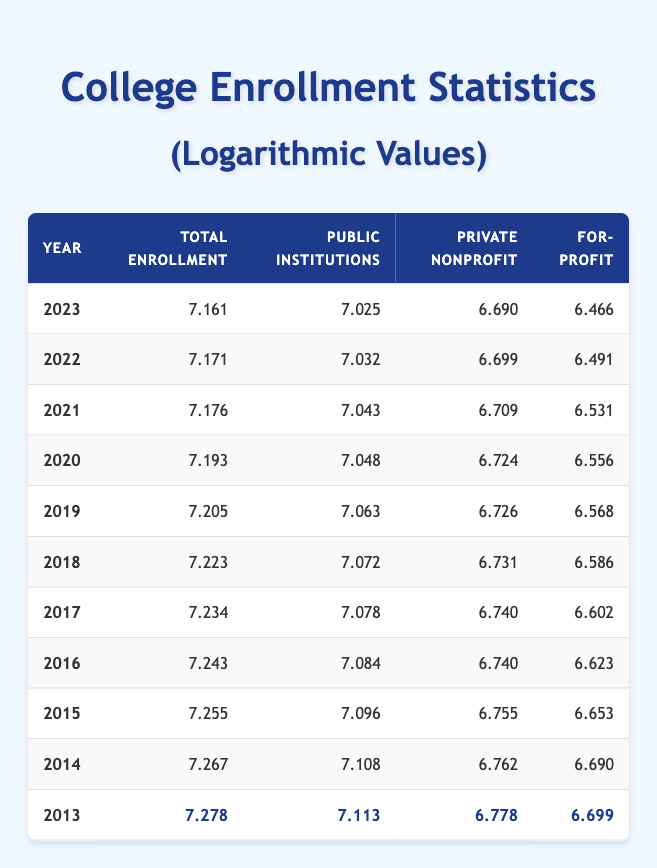What year had the highest total enrollment log value? The highest logarithmic value for total enrollment is 7.278, which corresponds to the year 2013.
Answer: 2013 What was the total enrollment in 2020? The total enrollment for the year 2020 is listed as 15600000 in the table.
Answer: 15600000 What was the difference in public institution enrollment from 2014 to 2017? The enrollment in public institutions was 12800000 in 2014 and 12100000 in 2017. The difference is 12800000 - 12100000 = 700000.
Answer: 700000 Which year experienced a decrease in for-profit enrollment compared to the previous year? Observing the for-profit enrollment values, 2021 had 3400000, which is less than 3600000 in 2020; hence, 2021 experienced a decrease.
Answer: 2021 Was the log value of private nonprofit enrollment higher in 2022 than in 2021? In 2021, the log value for private nonprofit enrollment was 6.709, whereas in 2022 it was 6.699, so 2022 did not exceed 2021.
Answer: No What was the average log value of total enrollment from 2013 to 2023? To calculate the average, sum the log values (7.278 + 7.267 + 7.255 + 7.243 + 7.234 + 7.223 + 7.205 + 7.193 + 7.176 + 7.171 + 7.161 = 79.202) and divide by the number of years (11). The average is 79.202 / 11 = 7.191.
Answer: 7.191 During which year was the enrollment in private nonprofit institutions the lowest? The values indicate that the enrollment in private nonprofit institutions was lowest at 4900000 in 2023.
Answer: 2023 What is the trend of total enrollment from 2013 to 2023? Total enrollment decreases yearly when examining the data from 2013 (19000000) down to 2023 (14500000), confirming a decreasing trend throughout the decade.
Answer: Decreasing trend 